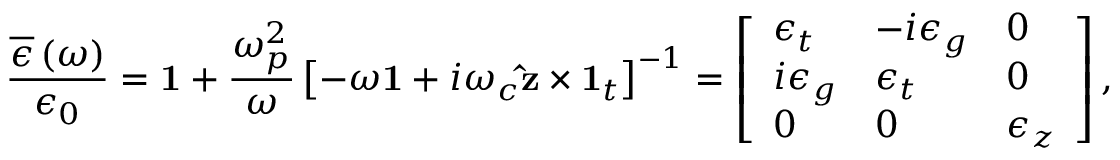<formula> <loc_0><loc_0><loc_500><loc_500>\frac { \overline { \epsilon } \left ( \omega \right ) } { \epsilon _ { 0 } } = 1 + \frac { \omega _ { p } ^ { 2 } } { \omega } \left [ - \omega 1 + i \omega _ { c } \hat { z } \times 1 _ { t } \right ] ^ { - 1 } = \left [ \begin{array} { l l l } { \epsilon _ { t } } & { - i \epsilon _ { g } } & { 0 } \\ { i \epsilon _ { g } } & { \epsilon _ { t } } & { 0 } \\ { 0 } & { 0 } & { \epsilon _ { z } } \end{array} \right ] ,</formula> 